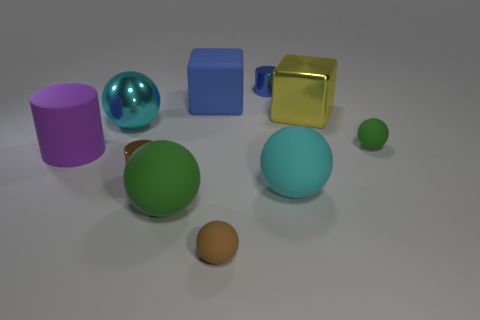Subtract 2 balls. How many balls are left? 3 Subtract all brown spheres. How many spheres are left? 4 Subtract all brown spheres. How many spheres are left? 4 Subtract all green balls. Subtract all purple cylinders. How many balls are left? 3 Subtract all cylinders. How many objects are left? 7 Add 7 brown cylinders. How many brown cylinders are left? 8 Add 6 big green rubber spheres. How many big green rubber spheres exist? 7 Subtract 1 blue blocks. How many objects are left? 9 Subtract all blue matte blocks. Subtract all purple things. How many objects are left? 8 